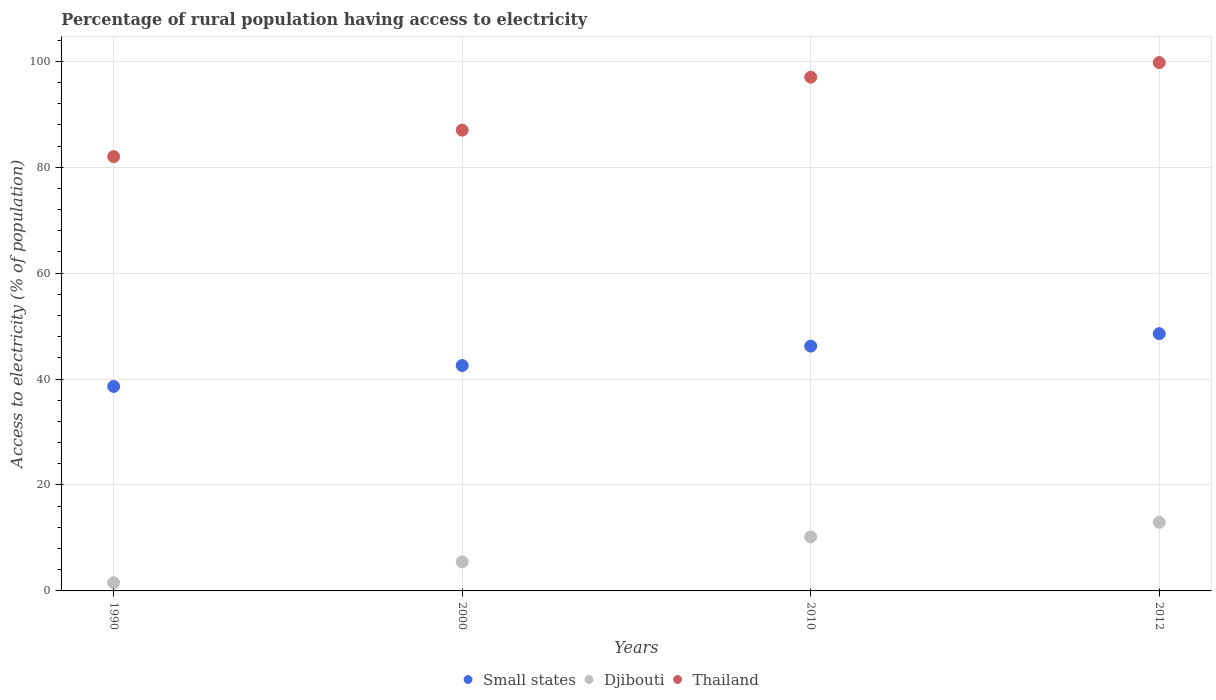What is the percentage of rural population having access to electricity in Djibouti in 2012?
Your answer should be very brief. 12.95. Across all years, what is the maximum percentage of rural population having access to electricity in Djibouti?
Give a very brief answer. 12.95. Across all years, what is the minimum percentage of rural population having access to electricity in Djibouti?
Offer a terse response. 1.56. In which year was the percentage of rural population having access to electricity in Djibouti maximum?
Offer a very short reply. 2012. In which year was the percentage of rural population having access to electricity in Thailand minimum?
Your response must be concise. 1990. What is the total percentage of rural population having access to electricity in Thailand in the graph?
Offer a terse response. 365.75. What is the difference between the percentage of rural population having access to electricity in Djibouti in 1990 and that in 2010?
Ensure brevity in your answer.  -8.64. What is the difference between the percentage of rural population having access to electricity in Small states in 2000 and the percentage of rural population having access to electricity in Thailand in 2012?
Provide a short and direct response. -57.19. What is the average percentage of rural population having access to electricity in Small states per year?
Make the answer very short. 43.99. In the year 2010, what is the difference between the percentage of rural population having access to electricity in Thailand and percentage of rural population having access to electricity in Small states?
Keep it short and to the point. 50.78. What is the ratio of the percentage of rural population having access to electricity in Djibouti in 2010 to that in 2012?
Your answer should be very brief. 0.79. Is the percentage of rural population having access to electricity in Small states in 1990 less than that in 2000?
Your answer should be compact. Yes. What is the difference between the highest and the second highest percentage of rural population having access to electricity in Small states?
Your answer should be compact. 2.35. What is the difference between the highest and the lowest percentage of rural population having access to electricity in Small states?
Make the answer very short. 9.96. Does the percentage of rural population having access to electricity in Djibouti monotonically increase over the years?
Offer a very short reply. Yes. Is the percentage of rural population having access to electricity in Djibouti strictly greater than the percentage of rural population having access to electricity in Thailand over the years?
Keep it short and to the point. No. How many years are there in the graph?
Offer a terse response. 4. What is the difference between two consecutive major ticks on the Y-axis?
Provide a succinct answer. 20. Are the values on the major ticks of Y-axis written in scientific E-notation?
Provide a succinct answer. No. Where does the legend appear in the graph?
Give a very brief answer. Bottom center. What is the title of the graph?
Provide a short and direct response. Percentage of rural population having access to electricity. What is the label or title of the Y-axis?
Ensure brevity in your answer.  Access to electricity (% of population). What is the Access to electricity (% of population) of Small states in 1990?
Offer a very short reply. 38.61. What is the Access to electricity (% of population) in Djibouti in 1990?
Keep it short and to the point. 1.56. What is the Access to electricity (% of population) of Small states in 2000?
Keep it short and to the point. 42.56. What is the Access to electricity (% of population) of Djibouti in 2000?
Provide a short and direct response. 5.48. What is the Access to electricity (% of population) of Thailand in 2000?
Provide a succinct answer. 87. What is the Access to electricity (% of population) of Small states in 2010?
Offer a terse response. 46.22. What is the Access to electricity (% of population) in Djibouti in 2010?
Your answer should be compact. 10.2. What is the Access to electricity (% of population) in Thailand in 2010?
Ensure brevity in your answer.  97. What is the Access to electricity (% of population) of Small states in 2012?
Provide a succinct answer. 48.57. What is the Access to electricity (% of population) of Djibouti in 2012?
Provide a succinct answer. 12.95. What is the Access to electricity (% of population) in Thailand in 2012?
Provide a succinct answer. 99.75. Across all years, what is the maximum Access to electricity (% of population) in Small states?
Your answer should be very brief. 48.57. Across all years, what is the maximum Access to electricity (% of population) of Djibouti?
Your response must be concise. 12.95. Across all years, what is the maximum Access to electricity (% of population) in Thailand?
Ensure brevity in your answer.  99.75. Across all years, what is the minimum Access to electricity (% of population) in Small states?
Offer a terse response. 38.61. Across all years, what is the minimum Access to electricity (% of population) of Djibouti?
Provide a succinct answer. 1.56. Across all years, what is the minimum Access to electricity (% of population) in Thailand?
Offer a terse response. 82. What is the total Access to electricity (% of population) of Small states in the graph?
Offer a very short reply. 175.96. What is the total Access to electricity (% of population) of Djibouti in the graph?
Give a very brief answer. 30.2. What is the total Access to electricity (% of population) in Thailand in the graph?
Provide a succinct answer. 365.75. What is the difference between the Access to electricity (% of population) in Small states in 1990 and that in 2000?
Provide a short and direct response. -3.95. What is the difference between the Access to electricity (% of population) of Djibouti in 1990 and that in 2000?
Your answer should be very brief. -3.92. What is the difference between the Access to electricity (% of population) of Small states in 1990 and that in 2010?
Keep it short and to the point. -7.62. What is the difference between the Access to electricity (% of population) in Djibouti in 1990 and that in 2010?
Offer a very short reply. -8.64. What is the difference between the Access to electricity (% of population) of Small states in 1990 and that in 2012?
Give a very brief answer. -9.96. What is the difference between the Access to electricity (% of population) in Djibouti in 1990 and that in 2012?
Ensure brevity in your answer.  -11.39. What is the difference between the Access to electricity (% of population) of Thailand in 1990 and that in 2012?
Your answer should be compact. -17.75. What is the difference between the Access to electricity (% of population) in Small states in 2000 and that in 2010?
Make the answer very short. -3.66. What is the difference between the Access to electricity (% of population) of Djibouti in 2000 and that in 2010?
Provide a short and direct response. -4.72. What is the difference between the Access to electricity (% of population) in Thailand in 2000 and that in 2010?
Ensure brevity in your answer.  -10. What is the difference between the Access to electricity (% of population) in Small states in 2000 and that in 2012?
Make the answer very short. -6.01. What is the difference between the Access to electricity (% of population) in Djibouti in 2000 and that in 2012?
Give a very brief answer. -7.47. What is the difference between the Access to electricity (% of population) of Thailand in 2000 and that in 2012?
Give a very brief answer. -12.75. What is the difference between the Access to electricity (% of population) of Small states in 2010 and that in 2012?
Provide a succinct answer. -2.35. What is the difference between the Access to electricity (% of population) in Djibouti in 2010 and that in 2012?
Offer a terse response. -2.75. What is the difference between the Access to electricity (% of population) in Thailand in 2010 and that in 2012?
Give a very brief answer. -2.75. What is the difference between the Access to electricity (% of population) of Small states in 1990 and the Access to electricity (% of population) of Djibouti in 2000?
Provide a short and direct response. 33.13. What is the difference between the Access to electricity (% of population) of Small states in 1990 and the Access to electricity (% of population) of Thailand in 2000?
Your response must be concise. -48.39. What is the difference between the Access to electricity (% of population) of Djibouti in 1990 and the Access to electricity (% of population) of Thailand in 2000?
Your answer should be compact. -85.44. What is the difference between the Access to electricity (% of population) in Small states in 1990 and the Access to electricity (% of population) in Djibouti in 2010?
Offer a terse response. 28.41. What is the difference between the Access to electricity (% of population) of Small states in 1990 and the Access to electricity (% of population) of Thailand in 2010?
Keep it short and to the point. -58.39. What is the difference between the Access to electricity (% of population) of Djibouti in 1990 and the Access to electricity (% of population) of Thailand in 2010?
Offer a very short reply. -95.44. What is the difference between the Access to electricity (% of population) of Small states in 1990 and the Access to electricity (% of population) of Djibouti in 2012?
Offer a very short reply. 25.65. What is the difference between the Access to electricity (% of population) in Small states in 1990 and the Access to electricity (% of population) in Thailand in 2012?
Your answer should be very brief. -61.15. What is the difference between the Access to electricity (% of population) in Djibouti in 1990 and the Access to electricity (% of population) in Thailand in 2012?
Provide a short and direct response. -98.19. What is the difference between the Access to electricity (% of population) in Small states in 2000 and the Access to electricity (% of population) in Djibouti in 2010?
Your response must be concise. 32.36. What is the difference between the Access to electricity (% of population) of Small states in 2000 and the Access to electricity (% of population) of Thailand in 2010?
Your response must be concise. -54.44. What is the difference between the Access to electricity (% of population) of Djibouti in 2000 and the Access to electricity (% of population) of Thailand in 2010?
Your answer should be compact. -91.52. What is the difference between the Access to electricity (% of population) of Small states in 2000 and the Access to electricity (% of population) of Djibouti in 2012?
Offer a very short reply. 29.61. What is the difference between the Access to electricity (% of population) of Small states in 2000 and the Access to electricity (% of population) of Thailand in 2012?
Offer a terse response. -57.19. What is the difference between the Access to electricity (% of population) in Djibouti in 2000 and the Access to electricity (% of population) in Thailand in 2012?
Ensure brevity in your answer.  -94.27. What is the difference between the Access to electricity (% of population) in Small states in 2010 and the Access to electricity (% of population) in Djibouti in 2012?
Keep it short and to the point. 33.27. What is the difference between the Access to electricity (% of population) of Small states in 2010 and the Access to electricity (% of population) of Thailand in 2012?
Give a very brief answer. -53.53. What is the difference between the Access to electricity (% of population) in Djibouti in 2010 and the Access to electricity (% of population) in Thailand in 2012?
Your answer should be compact. -89.55. What is the average Access to electricity (% of population) in Small states per year?
Offer a very short reply. 43.99. What is the average Access to electricity (% of population) in Djibouti per year?
Your answer should be compact. 7.55. What is the average Access to electricity (% of population) of Thailand per year?
Offer a very short reply. 91.44. In the year 1990, what is the difference between the Access to electricity (% of population) of Small states and Access to electricity (% of population) of Djibouti?
Offer a terse response. 37.05. In the year 1990, what is the difference between the Access to electricity (% of population) in Small states and Access to electricity (% of population) in Thailand?
Ensure brevity in your answer.  -43.39. In the year 1990, what is the difference between the Access to electricity (% of population) of Djibouti and Access to electricity (% of population) of Thailand?
Keep it short and to the point. -80.44. In the year 2000, what is the difference between the Access to electricity (% of population) in Small states and Access to electricity (% of population) in Djibouti?
Provide a short and direct response. 37.08. In the year 2000, what is the difference between the Access to electricity (% of population) of Small states and Access to electricity (% of population) of Thailand?
Provide a succinct answer. -44.44. In the year 2000, what is the difference between the Access to electricity (% of population) of Djibouti and Access to electricity (% of population) of Thailand?
Make the answer very short. -81.52. In the year 2010, what is the difference between the Access to electricity (% of population) in Small states and Access to electricity (% of population) in Djibouti?
Keep it short and to the point. 36.02. In the year 2010, what is the difference between the Access to electricity (% of population) of Small states and Access to electricity (% of population) of Thailand?
Your answer should be very brief. -50.78. In the year 2010, what is the difference between the Access to electricity (% of population) in Djibouti and Access to electricity (% of population) in Thailand?
Offer a terse response. -86.8. In the year 2012, what is the difference between the Access to electricity (% of population) of Small states and Access to electricity (% of population) of Djibouti?
Make the answer very short. 35.62. In the year 2012, what is the difference between the Access to electricity (% of population) of Small states and Access to electricity (% of population) of Thailand?
Your response must be concise. -51.18. In the year 2012, what is the difference between the Access to electricity (% of population) in Djibouti and Access to electricity (% of population) in Thailand?
Give a very brief answer. -86.8. What is the ratio of the Access to electricity (% of population) in Small states in 1990 to that in 2000?
Give a very brief answer. 0.91. What is the ratio of the Access to electricity (% of population) of Djibouti in 1990 to that in 2000?
Your response must be concise. 0.28. What is the ratio of the Access to electricity (% of population) in Thailand in 1990 to that in 2000?
Your response must be concise. 0.94. What is the ratio of the Access to electricity (% of population) of Small states in 1990 to that in 2010?
Provide a short and direct response. 0.84. What is the ratio of the Access to electricity (% of population) of Djibouti in 1990 to that in 2010?
Your answer should be compact. 0.15. What is the ratio of the Access to electricity (% of population) in Thailand in 1990 to that in 2010?
Your response must be concise. 0.85. What is the ratio of the Access to electricity (% of population) of Small states in 1990 to that in 2012?
Offer a terse response. 0.79. What is the ratio of the Access to electricity (% of population) of Djibouti in 1990 to that in 2012?
Keep it short and to the point. 0.12. What is the ratio of the Access to electricity (% of population) of Thailand in 1990 to that in 2012?
Keep it short and to the point. 0.82. What is the ratio of the Access to electricity (% of population) of Small states in 2000 to that in 2010?
Ensure brevity in your answer.  0.92. What is the ratio of the Access to electricity (% of population) of Djibouti in 2000 to that in 2010?
Make the answer very short. 0.54. What is the ratio of the Access to electricity (% of population) in Thailand in 2000 to that in 2010?
Make the answer very short. 0.9. What is the ratio of the Access to electricity (% of population) in Small states in 2000 to that in 2012?
Your answer should be very brief. 0.88. What is the ratio of the Access to electricity (% of population) of Djibouti in 2000 to that in 2012?
Ensure brevity in your answer.  0.42. What is the ratio of the Access to electricity (% of population) of Thailand in 2000 to that in 2012?
Your response must be concise. 0.87. What is the ratio of the Access to electricity (% of population) in Small states in 2010 to that in 2012?
Your answer should be compact. 0.95. What is the ratio of the Access to electricity (% of population) in Djibouti in 2010 to that in 2012?
Offer a terse response. 0.79. What is the ratio of the Access to electricity (% of population) in Thailand in 2010 to that in 2012?
Your response must be concise. 0.97. What is the difference between the highest and the second highest Access to electricity (% of population) in Small states?
Give a very brief answer. 2.35. What is the difference between the highest and the second highest Access to electricity (% of population) in Djibouti?
Provide a succinct answer. 2.75. What is the difference between the highest and the second highest Access to electricity (% of population) in Thailand?
Ensure brevity in your answer.  2.75. What is the difference between the highest and the lowest Access to electricity (% of population) of Small states?
Your response must be concise. 9.96. What is the difference between the highest and the lowest Access to electricity (% of population) in Djibouti?
Your answer should be very brief. 11.39. What is the difference between the highest and the lowest Access to electricity (% of population) of Thailand?
Offer a very short reply. 17.75. 